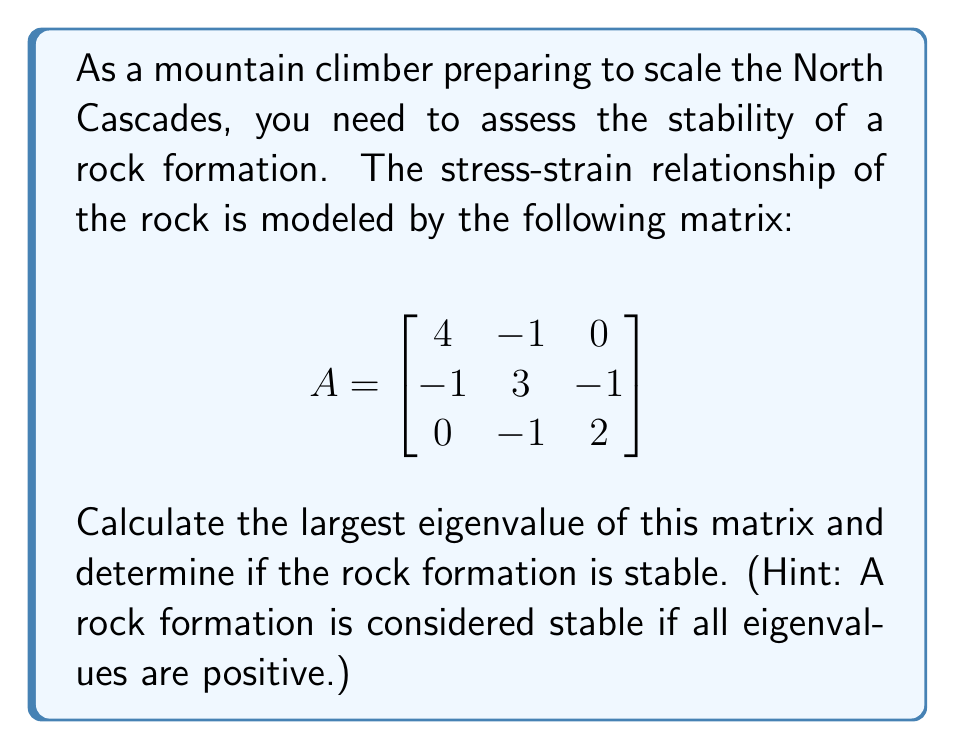Teach me how to tackle this problem. To determine the stability of the rock formation, we need to find the eigenvalues of matrix A. The largest eigenvalue will be particularly important for our stability analysis.

Step 1: Set up the characteristic equation
$det(A - \lambda I) = 0$

Step 2: Expand the determinant
$$\begin{vmatrix}
4-\lambda & -1 & 0 \\
-1 & 3-\lambda & -1 \\
0 & -1 & 2-\lambda
\end{vmatrix} = 0$$

Step 3: Calculate the determinant
$(4-\lambda)[(3-\lambda)(2-\lambda) - 1] - (-1)[(-1)(2-\lambda) - 0] = 0$

Step 4: Simplify
$(4-\lambda)(6-5\lambda+\lambda^2) + (2-\lambda) = 0$
$24-20\lambda+4\lambda^2-6\lambda+5\lambda^2-\lambda^3+2-\lambda = 0$
$-\lambda^3+9\lambda^2-27\lambda+26 = 0$

Step 5: Factor the cubic equation
$(\lambda-2)(\lambda-3)(\lambda-4) = 0$

Step 6: Solve for λ
The eigenvalues are $\lambda_1 = 2$, $\lambda_2 = 3$, and $\lambda_3 = 4$

Step 7: Identify the largest eigenvalue
The largest eigenvalue is $\lambda_{max} = 4$

Step 8: Assess stability
Since all eigenvalues (2, 3, and 4) are positive, the rock formation is stable.
Answer: Largest eigenvalue: 4; Rock formation is stable 